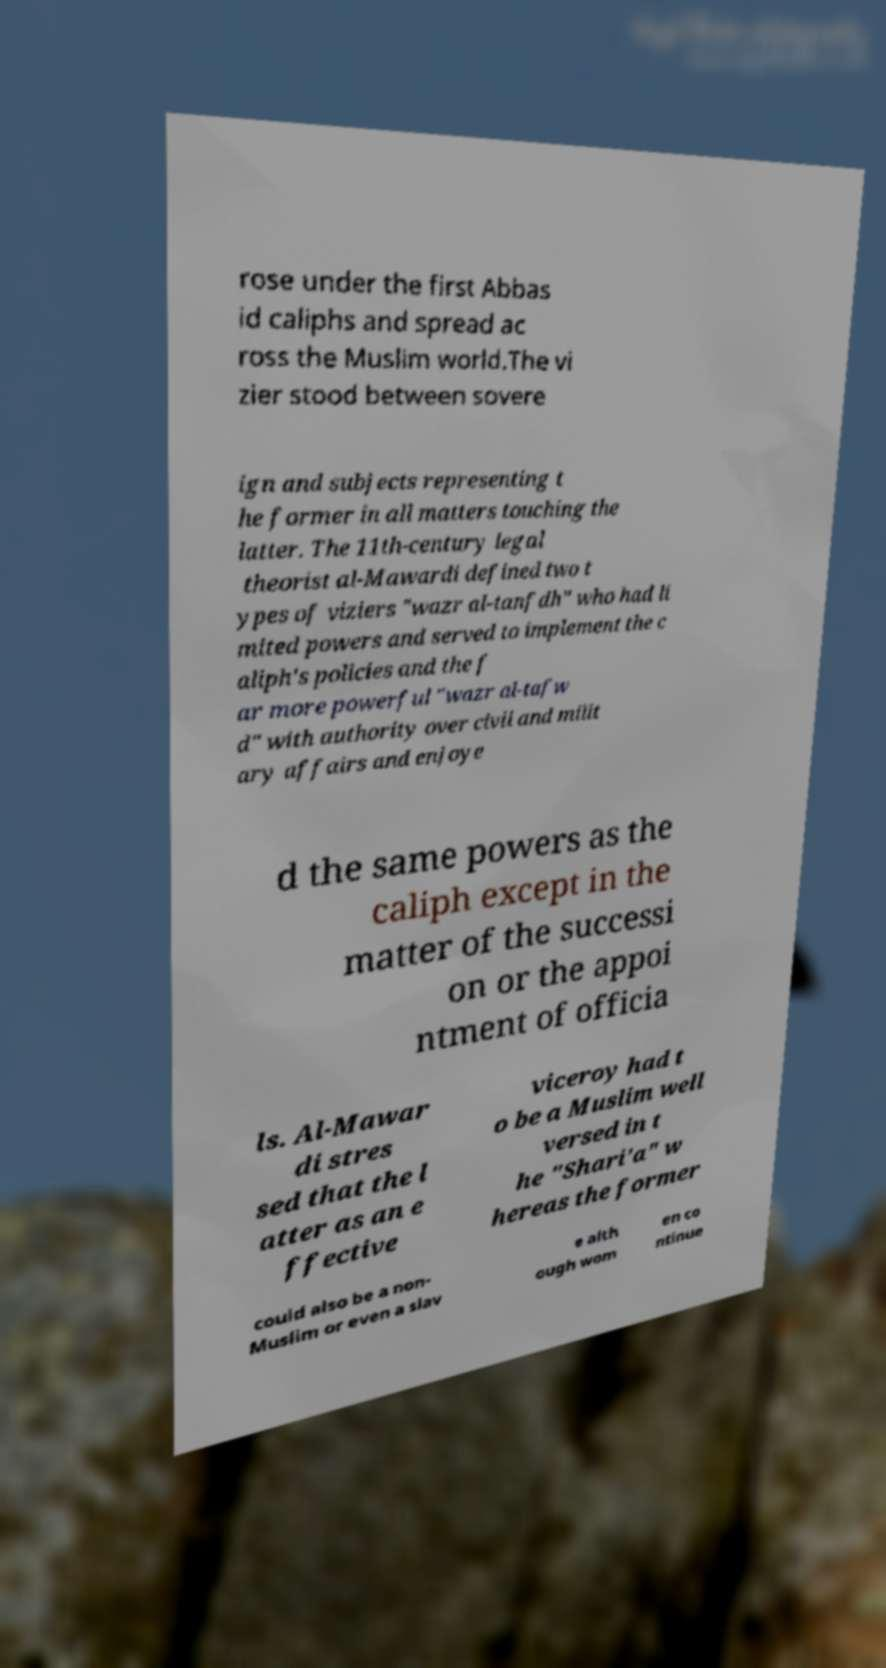Could you extract and type out the text from this image? rose under the first Abbas id caliphs and spread ac ross the Muslim world.The vi zier stood between sovere ign and subjects representing t he former in all matters touching the latter. The 11th-century legal theorist al-Mawardi defined two t ypes of viziers "wazr al-tanfdh" who had li mited powers and served to implement the c aliph's policies and the f ar more powerful "wazr al-tafw d" with authority over civil and milit ary affairs and enjoye d the same powers as the caliph except in the matter of the successi on or the appoi ntment of officia ls. Al-Mawar di stres sed that the l atter as an e ffective viceroy had t o be a Muslim well versed in t he "Shari'a" w hereas the former could also be a non- Muslim or even a slav e alth ough wom en co ntinue 